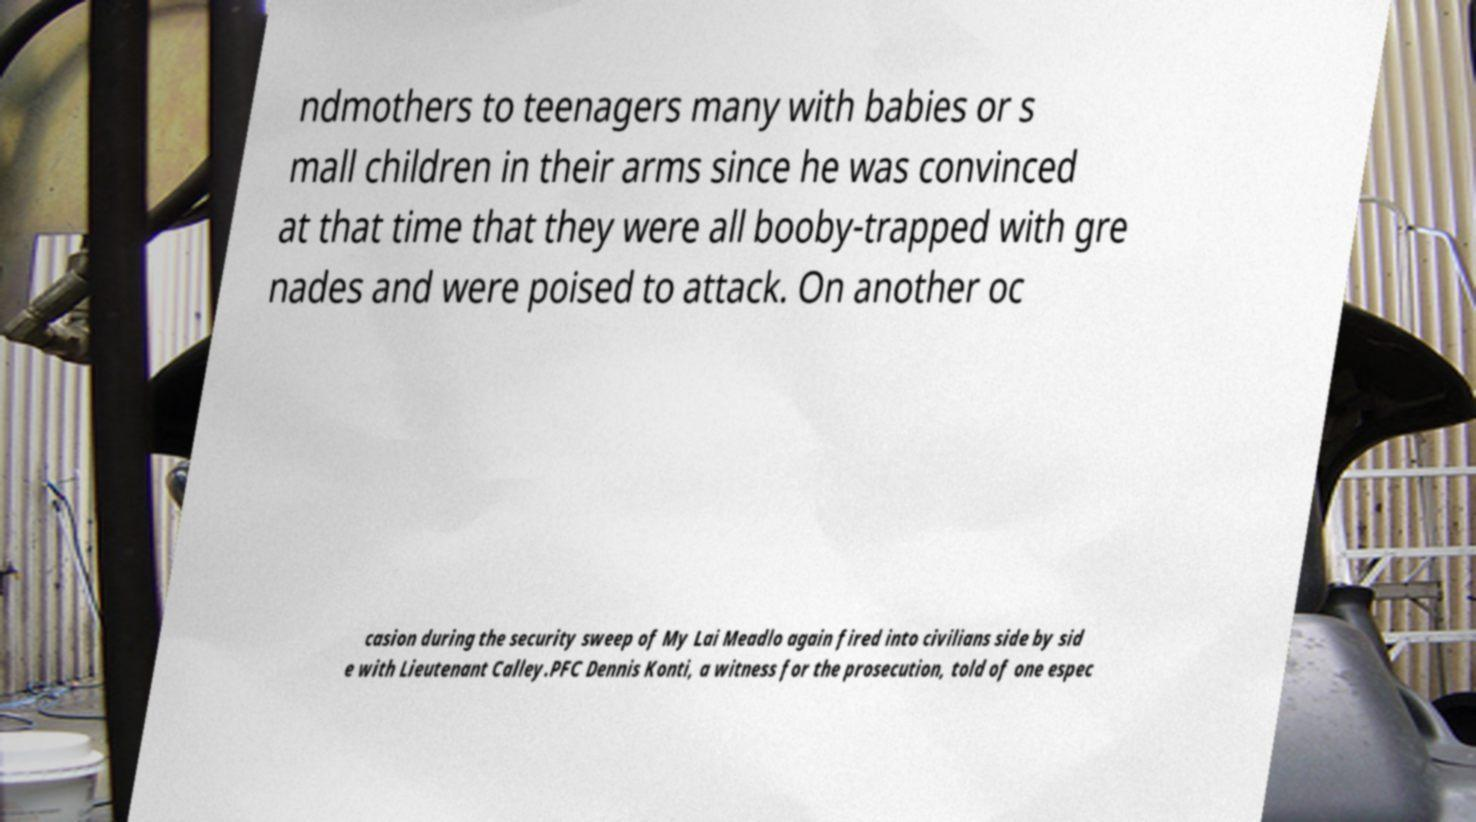There's text embedded in this image that I need extracted. Can you transcribe it verbatim? ndmothers to teenagers many with babies or s mall children in their arms since he was convinced at that time that they were all booby-trapped with gre nades and were poised to attack. On another oc casion during the security sweep of My Lai Meadlo again fired into civilians side by sid e with Lieutenant Calley.PFC Dennis Konti, a witness for the prosecution, told of one espec 